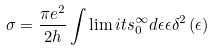Convert formula to latex. <formula><loc_0><loc_0><loc_500><loc_500>\sigma = \frac { \pi e ^ { 2 } } { 2 h } \int \lim i t s _ { 0 } ^ { \infty } d \epsilon \epsilon \delta ^ { 2 } \left ( \epsilon \right )</formula> 